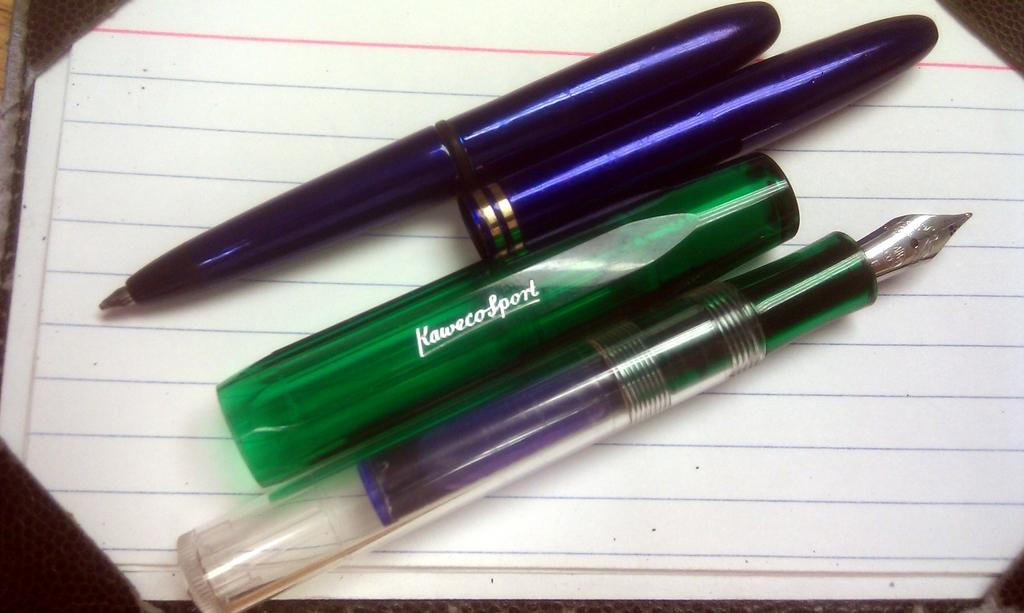What objects are present in the image? There are pens and caps in the image. Where are the pens and caps located? The pens and caps are on a paper. Can you see a kettle boiling water in the image? There is no kettle or boiling water present in the image. Is there a bridge connecting two areas in the image? There is no bridge connecting two areas present in the image. 